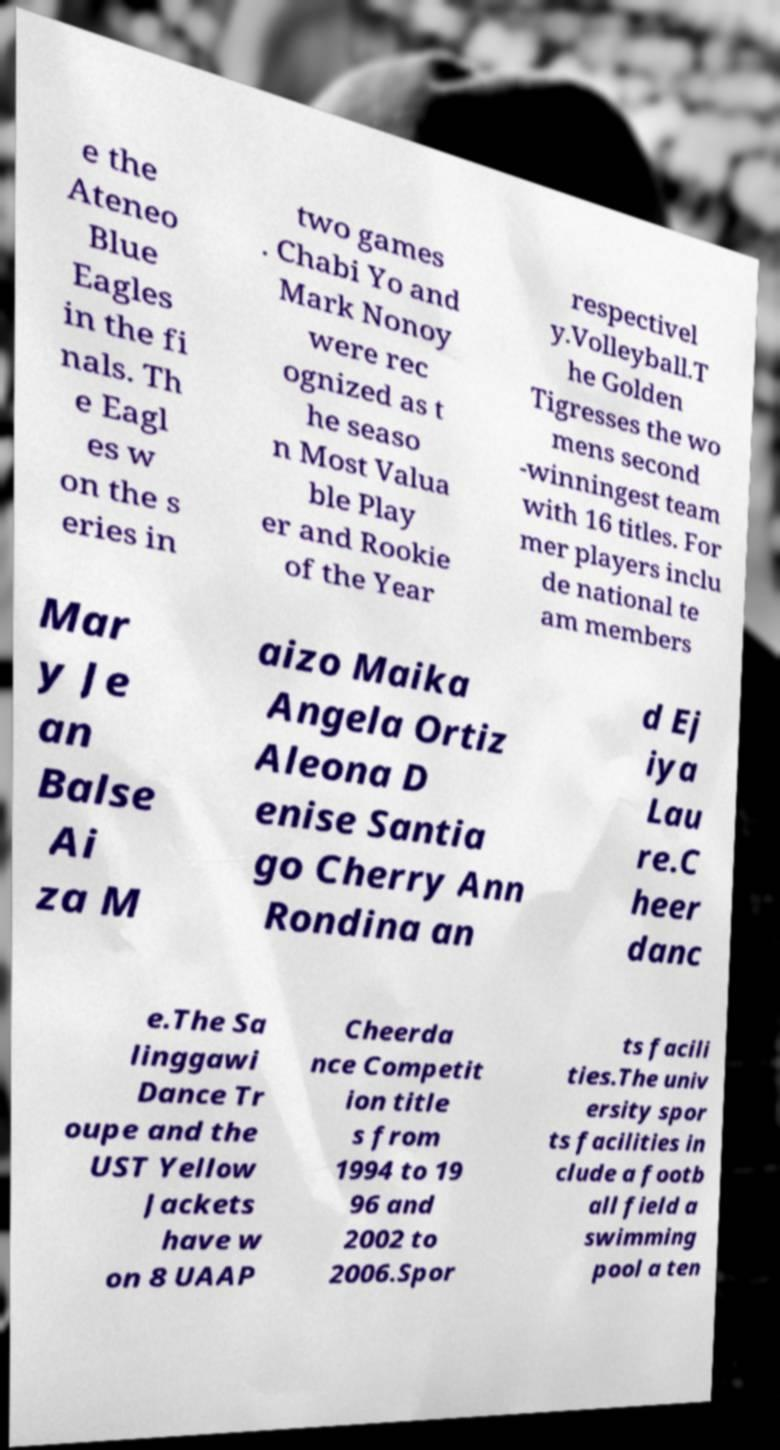Can you read and provide the text displayed in the image?This photo seems to have some interesting text. Can you extract and type it out for me? e the Ateneo Blue Eagles in the fi nals. Th e Eagl es w on the s eries in two games . Chabi Yo and Mark Nonoy were rec ognized as t he seaso n Most Valua ble Play er and Rookie of the Year respectivel y.Volleyball.T he Golden Tigresses the wo mens second -winningest team with 16 titles. For mer players inclu de national te am members Mar y Je an Balse Ai za M aizo Maika Angela Ortiz Aleona D enise Santia go Cherry Ann Rondina an d Ej iya Lau re.C heer danc e.The Sa linggawi Dance Tr oupe and the UST Yellow Jackets have w on 8 UAAP Cheerda nce Competit ion title s from 1994 to 19 96 and 2002 to 2006.Spor ts facili ties.The univ ersity spor ts facilities in clude a footb all field a swimming pool a ten 